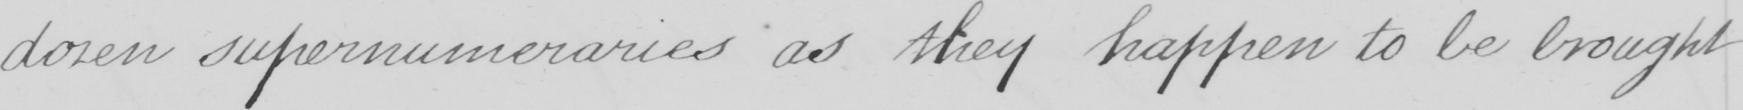What text is written in this handwritten line? dozen supernumeraries as they happen to be brought 